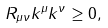Convert formula to latex. <formula><loc_0><loc_0><loc_500><loc_500>R _ { \mu \nu } k ^ { \mu } k ^ { \nu } \geq 0 ,</formula> 